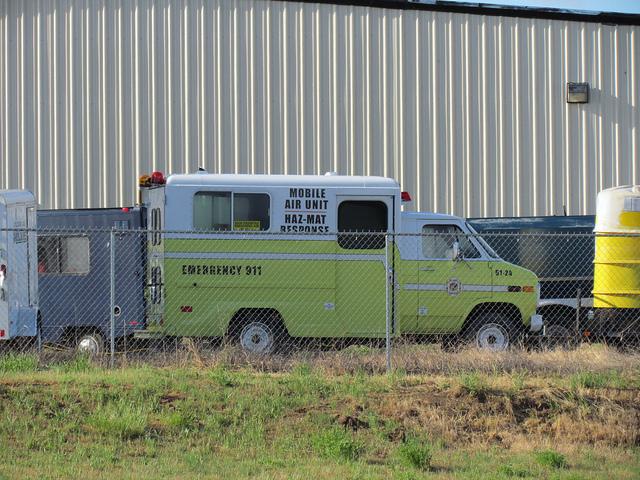What color is the bottom half of this truck?
Write a very short answer. Yellow. Is this a sunny day?
Write a very short answer. Yes. What does the word to the left of "911" say?
Quick response, please. Emergency. 